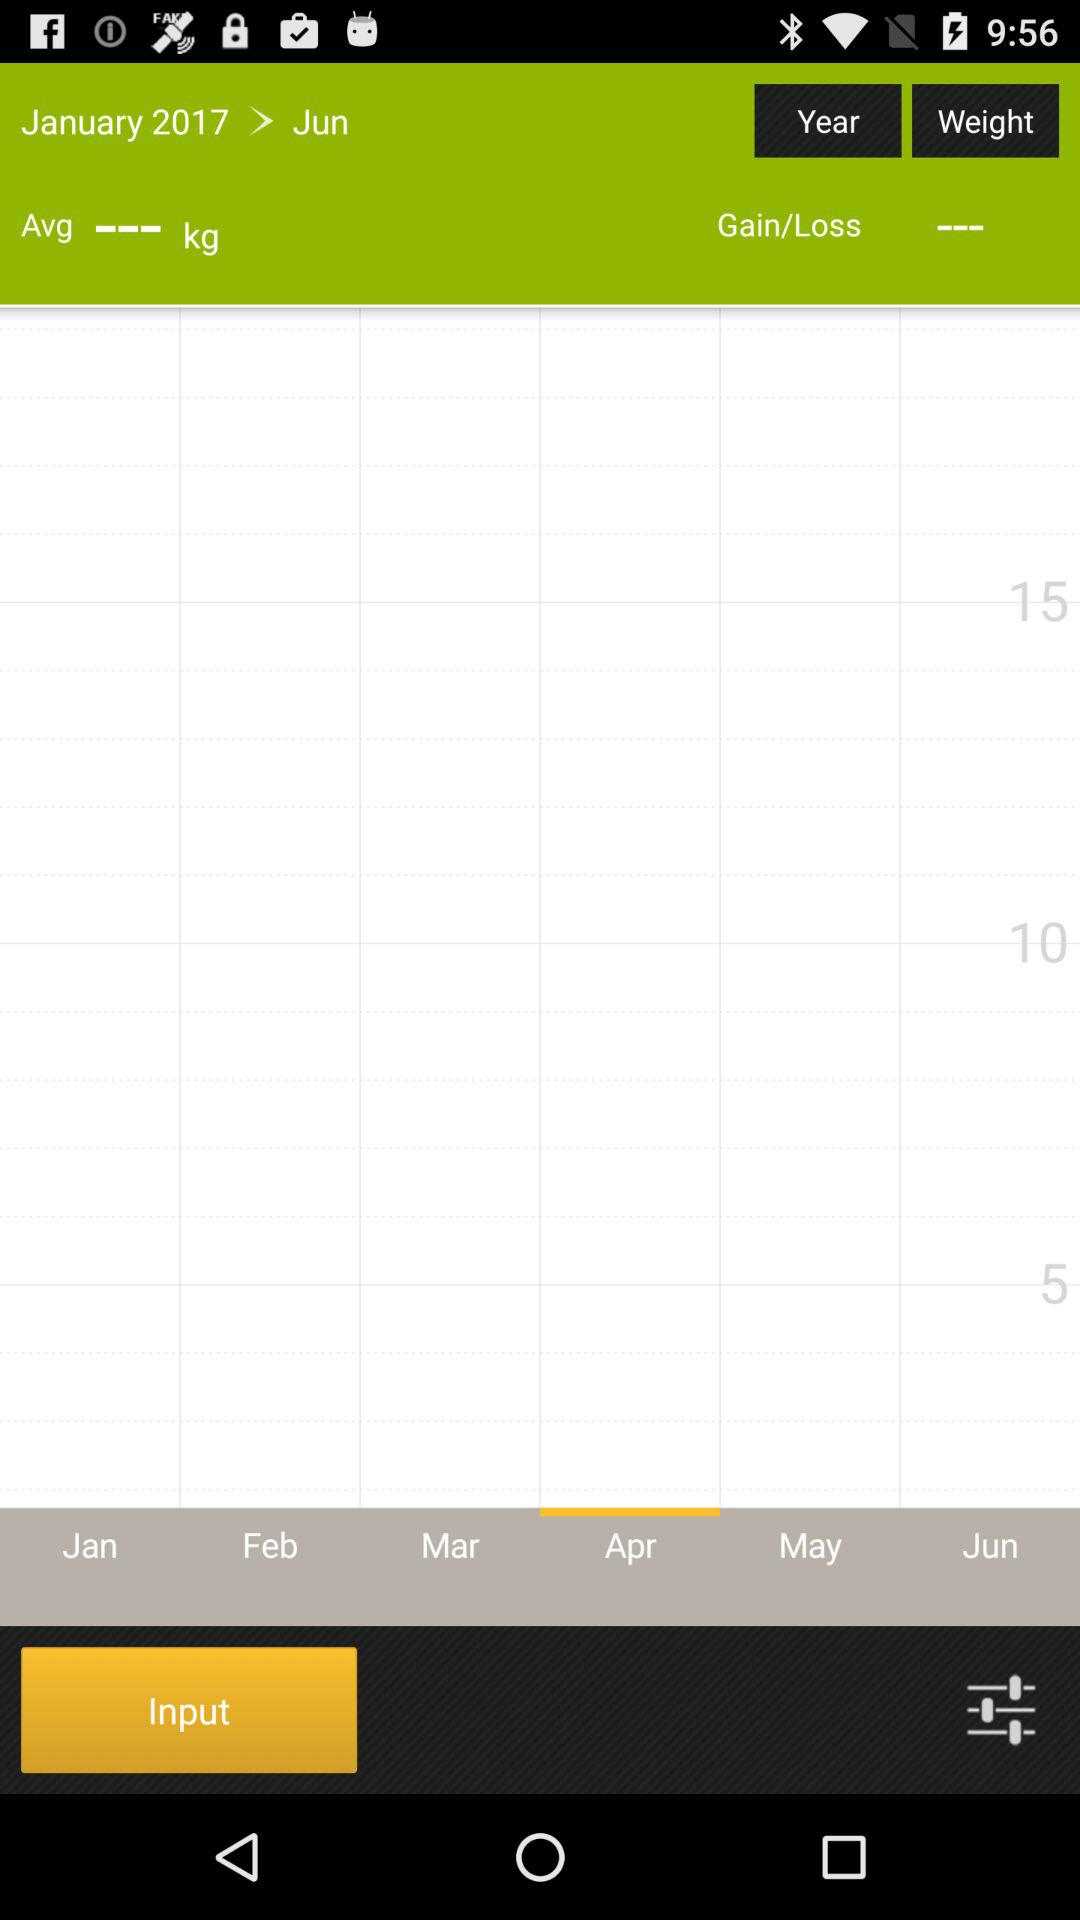What is the year? The year is 2017. 